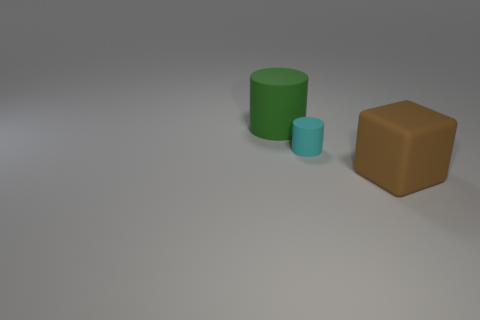Are there more cylinders right of the green object than large matte cylinders on the right side of the brown matte thing?
Make the answer very short. Yes. What is the material of the big brown cube?
Keep it short and to the point. Rubber. What is the shape of the large rubber thing that is to the left of the large rubber thing that is in front of the rubber thing that is behind the tiny cylinder?
Provide a succinct answer. Cylinder. What number of other things are the same material as the tiny cyan cylinder?
Offer a very short reply. 2. Is the material of the large object that is on the left side of the tiny rubber cylinder the same as the object in front of the tiny matte object?
Ensure brevity in your answer.  Yes. How many rubber objects are both to the left of the small rubber cylinder and in front of the large green matte cylinder?
Give a very brief answer. 0. Is there a large green matte thing of the same shape as the tiny thing?
Make the answer very short. Yes. What is the shape of the matte object that is the same size as the brown cube?
Offer a terse response. Cylinder. Are there an equal number of big things to the right of the brown block and small cyan matte objects that are behind the small cylinder?
Offer a very short reply. Yes. There is a matte cylinder that is in front of the object that is to the left of the tiny cyan rubber cylinder; what size is it?
Provide a succinct answer. Small. 